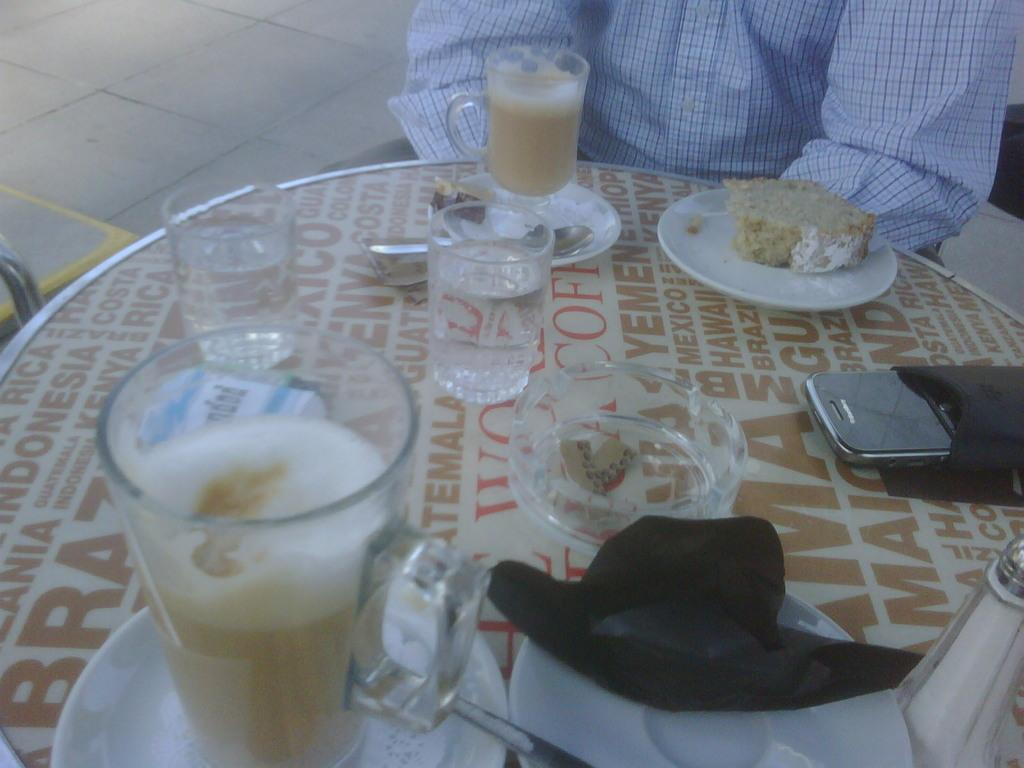What types of consumables are present in the image? There are food items and drinks in the image. Where are the food items and drinks located? Both the food items and drinks are on a table. How many pigs are present in the image? There are no pigs present in the image. What type of cover is used for the drinks in the image? The provided facts do not mention any covers for the drinks in the image. 